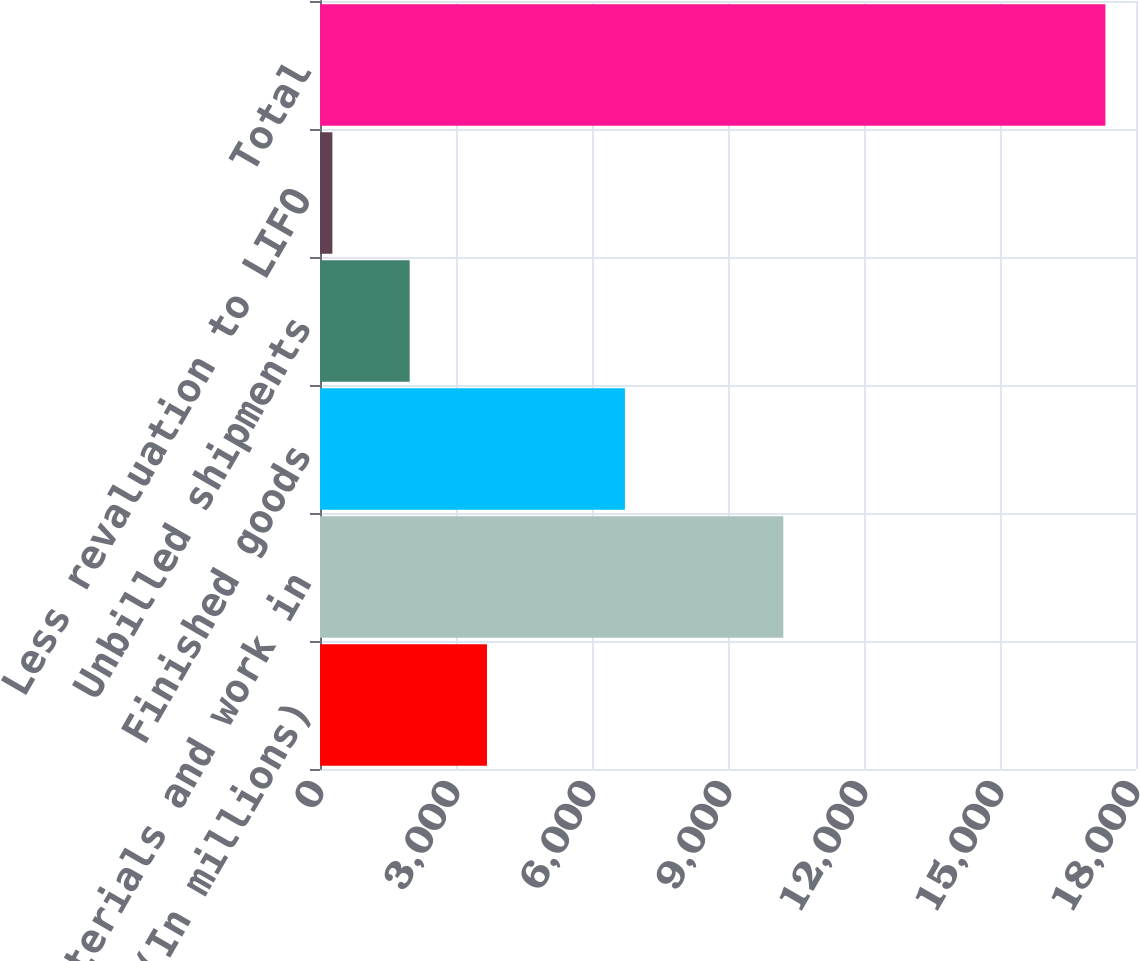Convert chart to OTSL. <chart><loc_0><loc_0><loc_500><loc_500><bar_chart><fcel>December 31 (In millions)<fcel>Raw materials and work in<fcel>Finished goods<fcel>Unbilled shipments<fcel>Less revaluation to LIFO<fcel>Total<nl><fcel>3683.4<fcel>10220<fcel>6726<fcel>1978.2<fcel>273<fcel>17325<nl></chart> 